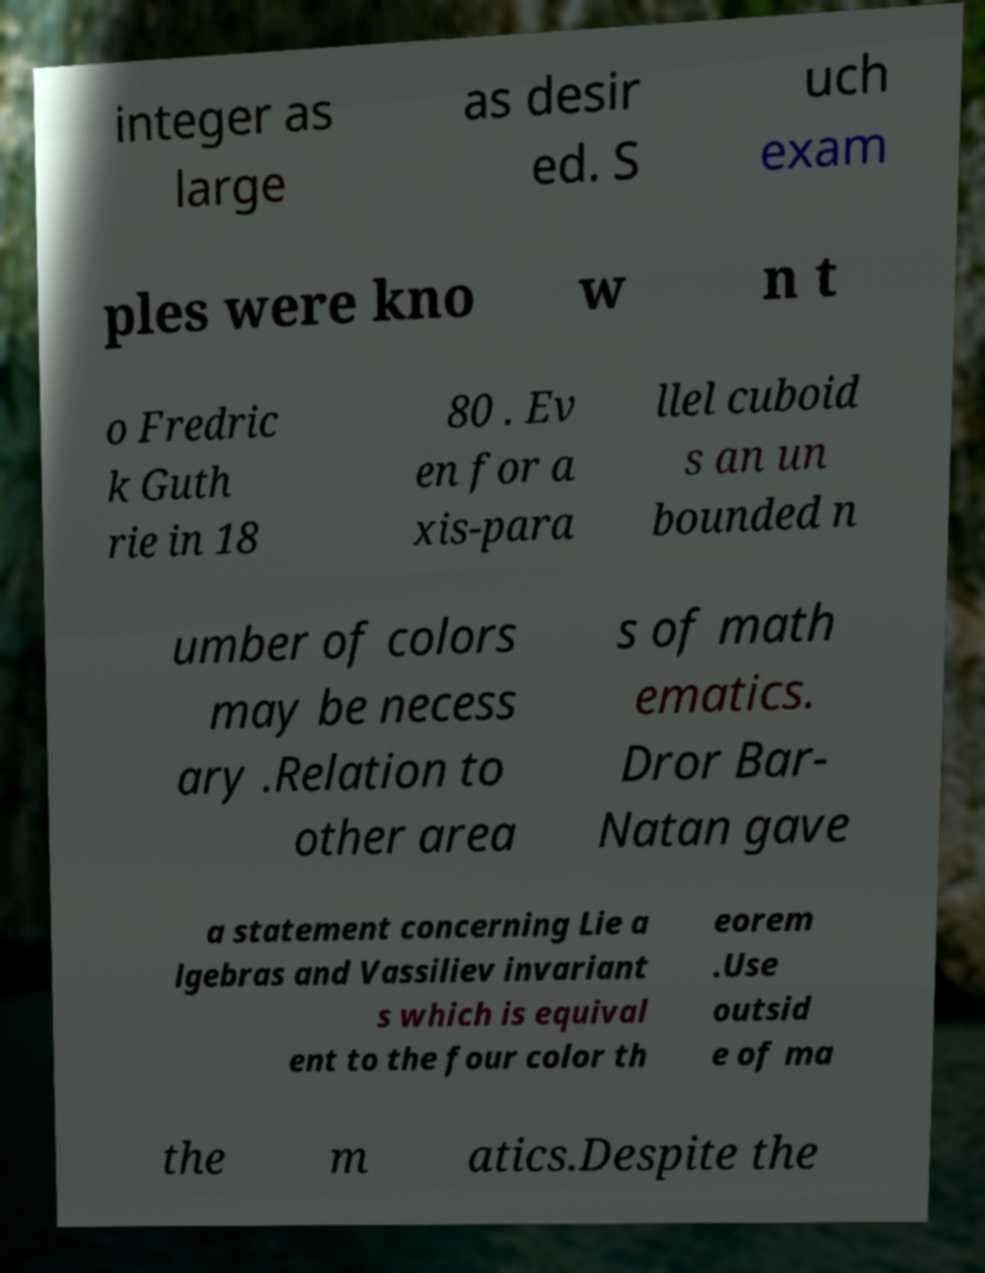Please identify and transcribe the text found in this image. integer as large as desir ed. S uch exam ples were kno w n t o Fredric k Guth rie in 18 80 . Ev en for a xis-para llel cuboid s an un bounded n umber of colors may be necess ary .Relation to other area s of math ematics. Dror Bar- Natan gave a statement concerning Lie a lgebras and Vassiliev invariant s which is equival ent to the four color th eorem .Use outsid e of ma the m atics.Despite the 